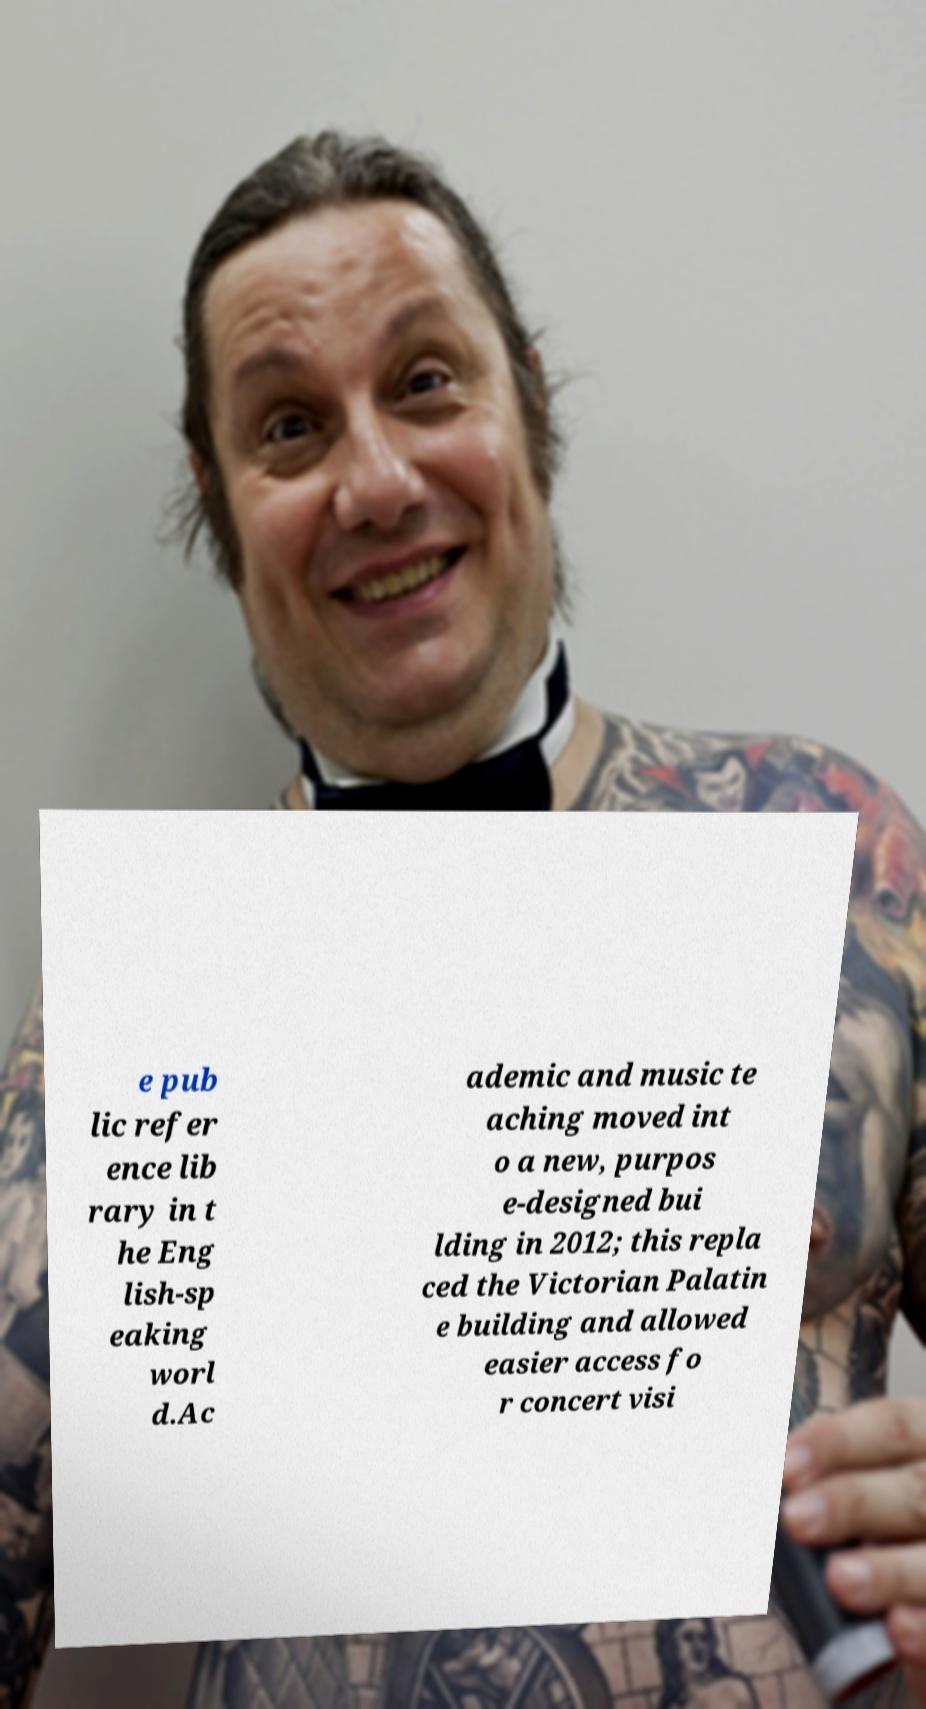What messages or text are displayed in this image? I need them in a readable, typed format. e pub lic refer ence lib rary in t he Eng lish-sp eaking worl d.Ac ademic and music te aching moved int o a new, purpos e-designed bui lding in 2012; this repla ced the Victorian Palatin e building and allowed easier access fo r concert visi 